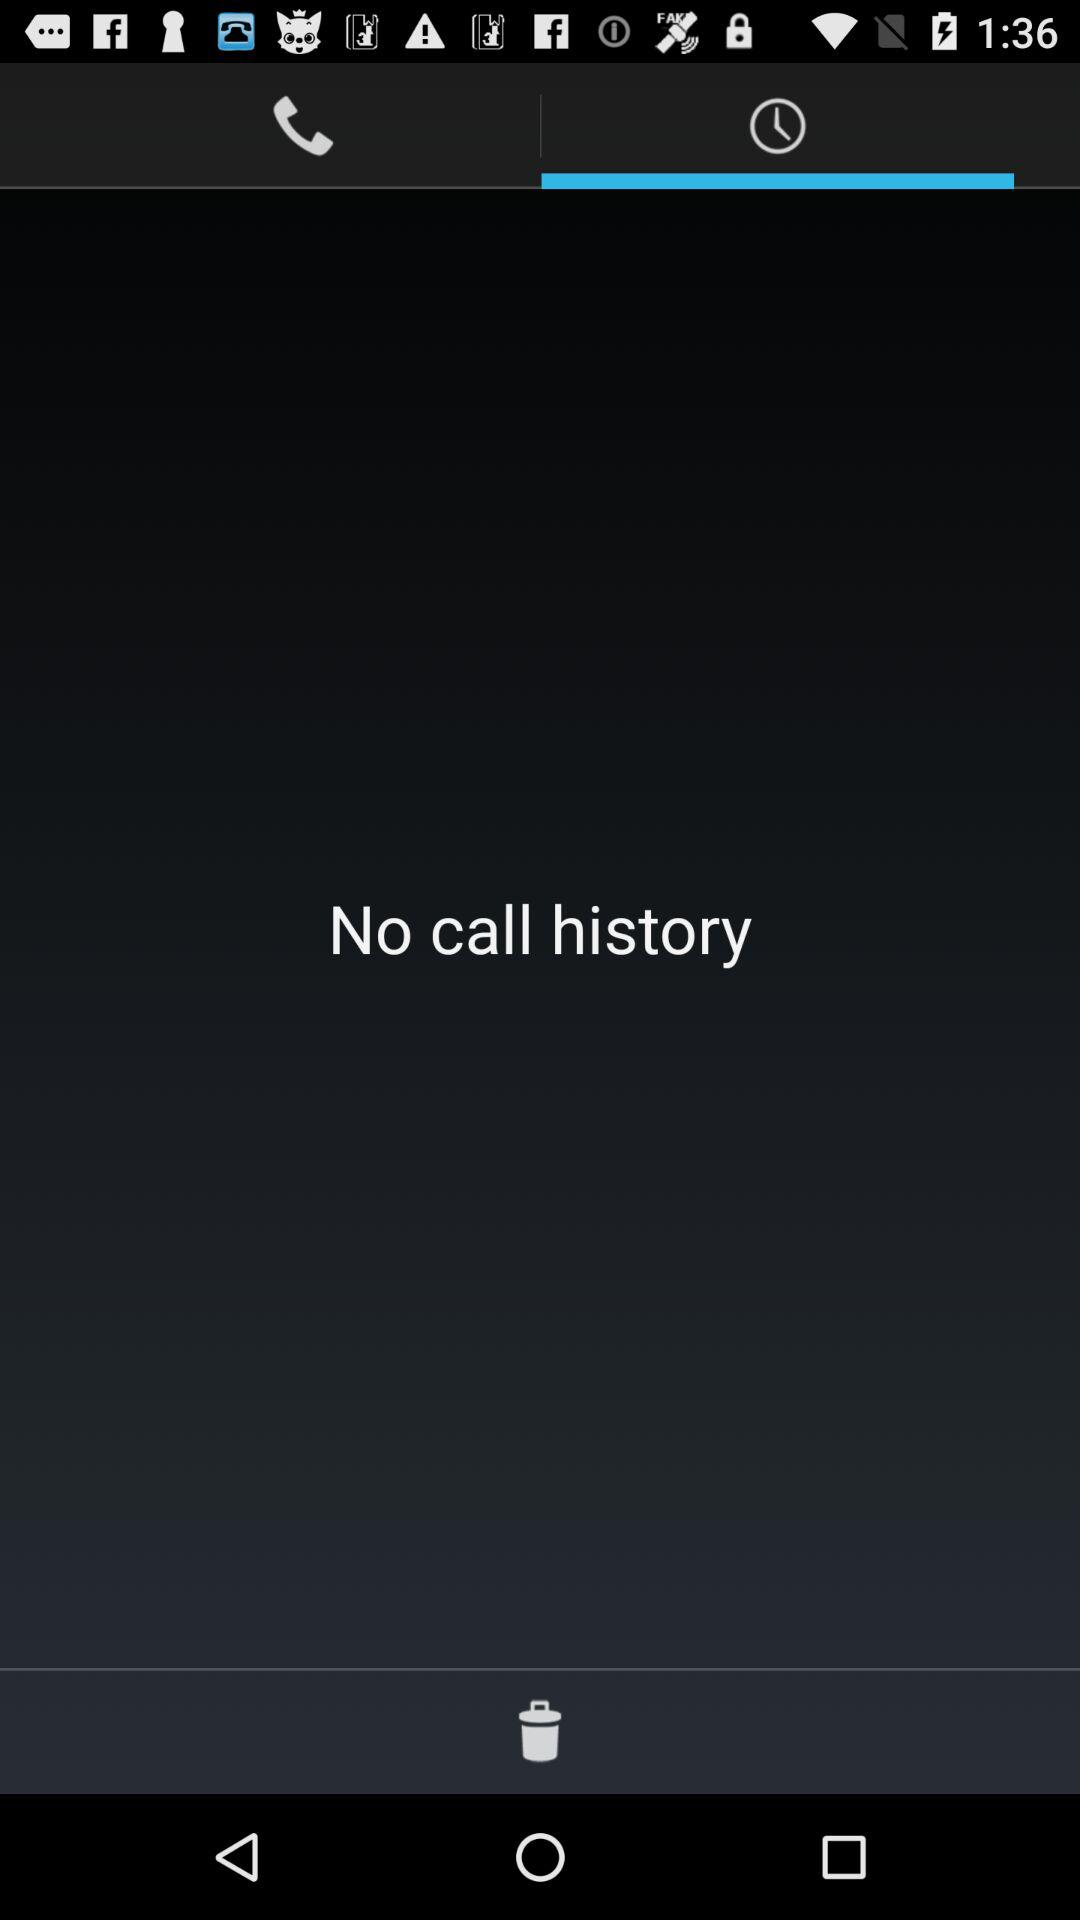How many call history items are there?
Answer the question using a single word or phrase. 0 